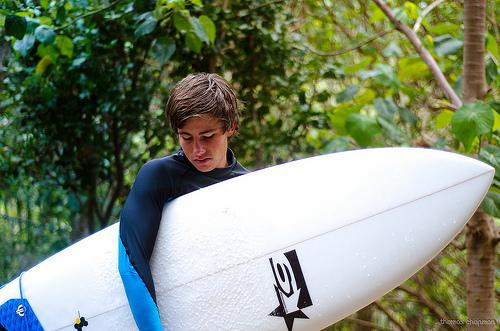Question: what is the boy holding?
Choices:
A. A surfboard.
B. A baseball bat.
C. A beach ball.
D. An oar.
Answer with the letter. Answer: A Question: what is the boy wearing?
Choices:
A. Swimsuit.
B. Wetsuit.
C. Baseball uniform.
D. Basketball shorts.
Answer with the letter. Answer: B Question: what number is on the surfboard?
Choices:
A. Six.
B. Seven.
C. Eight.
D. Nine.
Answer with the letter. Answer: A 